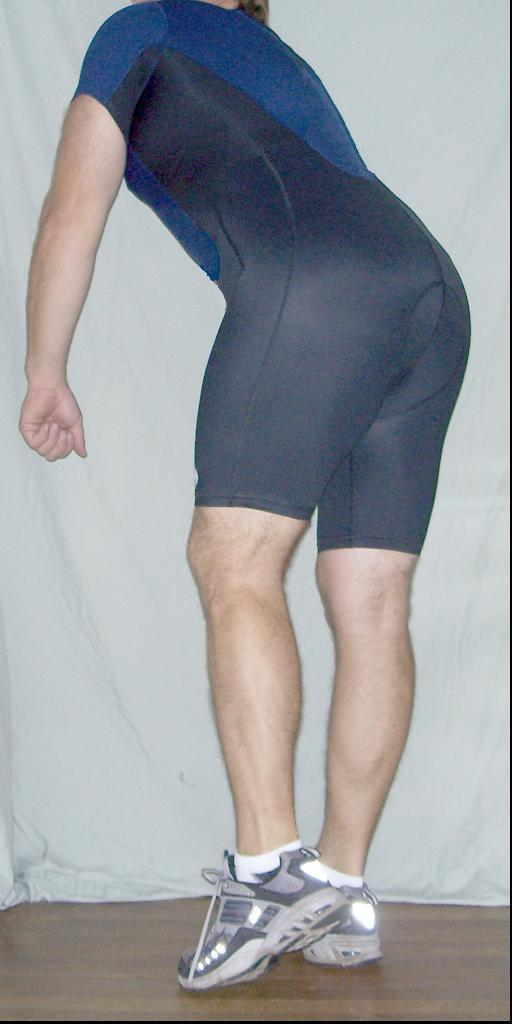Who or what is present in the image? There is a person in the image. What is the person's position in the image? The person is on the floor. What can be seen in the background of the image? There is a white cloth in the background of the image. What type of worm can be seen crawling on the person in the image? There is no worm present in the image; it only features a person on the floor and a white cloth in the background. 